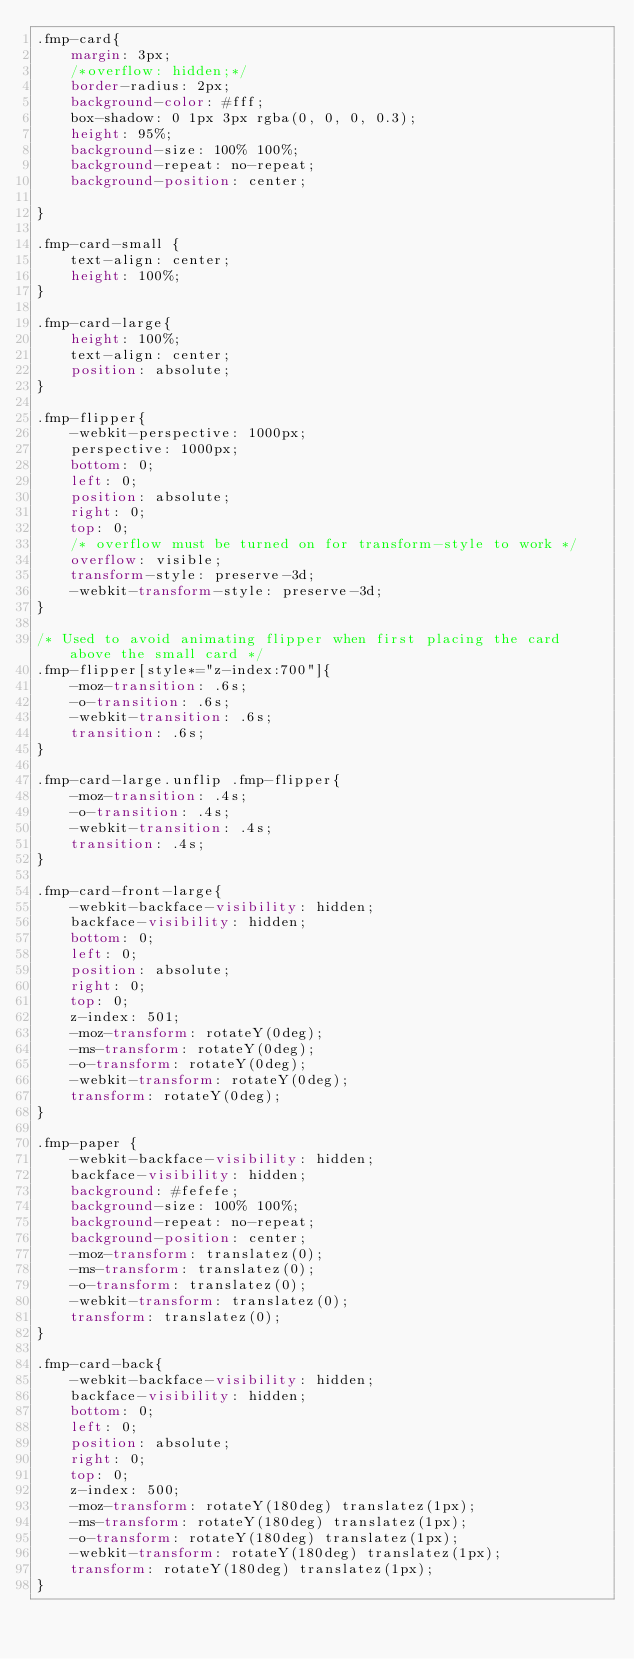Convert code to text. <code><loc_0><loc_0><loc_500><loc_500><_CSS_>.fmp-card{
    margin: 3px;
    /*overflow: hidden;*/
    border-radius: 2px;
    background-color: #fff;
    box-shadow: 0 1px 3px rgba(0, 0, 0, 0.3);
    height: 95%;
    background-size: 100% 100%;
    background-repeat: no-repeat;
    background-position: center;

}

.fmp-card-small {
    text-align: center;
    height: 100%;
}

.fmp-card-large{
    height: 100%;
    text-align: center;
    position: absolute;
}

.fmp-flipper{
    -webkit-perspective: 1000px;
    perspective: 1000px;
    bottom: 0;
    left: 0;
    position: absolute;
    right: 0;
    top: 0;
    /* overflow must be turned on for transform-style to work */
    overflow: visible;
    transform-style: preserve-3d;
    -webkit-transform-style: preserve-3d;
}

/* Used to avoid animating flipper when first placing the card above the small card */
.fmp-flipper[style*="z-index:700"]{
    -moz-transition: .6s;
    -o-transition: .6s;
    -webkit-transition: .6s;
    transition: .6s;
}

.fmp-card-large.unflip .fmp-flipper{
    -moz-transition: .4s;
    -o-transition: .4s;
    -webkit-transition: .4s;
    transition: .4s;
}

.fmp-card-front-large{
    -webkit-backface-visibility: hidden;
    backface-visibility: hidden;
    bottom: 0;
    left: 0;
    position: absolute;
    right: 0;
    top: 0;
    z-index: 501;
    -moz-transform: rotateY(0deg);
    -ms-transform: rotateY(0deg);
    -o-transform: rotateY(0deg);
    -webkit-transform: rotateY(0deg);
    transform: rotateY(0deg);
}

.fmp-paper {
    -webkit-backface-visibility: hidden;
    backface-visibility: hidden;
    background: #fefefe;
    background-size: 100% 100%;
    background-repeat: no-repeat;
    background-position: center;
    -moz-transform: translatez(0);
    -ms-transform: translatez(0);
    -o-transform: translatez(0);
    -webkit-transform: translatez(0);
    transform: translatez(0);
}

.fmp-card-back{
    -webkit-backface-visibility: hidden;
    backface-visibility: hidden;
    bottom: 0;
    left: 0;
    position: absolute;
    right: 0;
    top: 0;
    z-index: 500;
    -moz-transform: rotateY(180deg) translatez(1px);
    -ms-transform: rotateY(180deg) translatez(1px);
    -o-transform: rotateY(180deg) translatez(1px);
    -webkit-transform: rotateY(180deg) translatez(1px);
    transform: rotateY(180deg) translatez(1px);
}</code> 